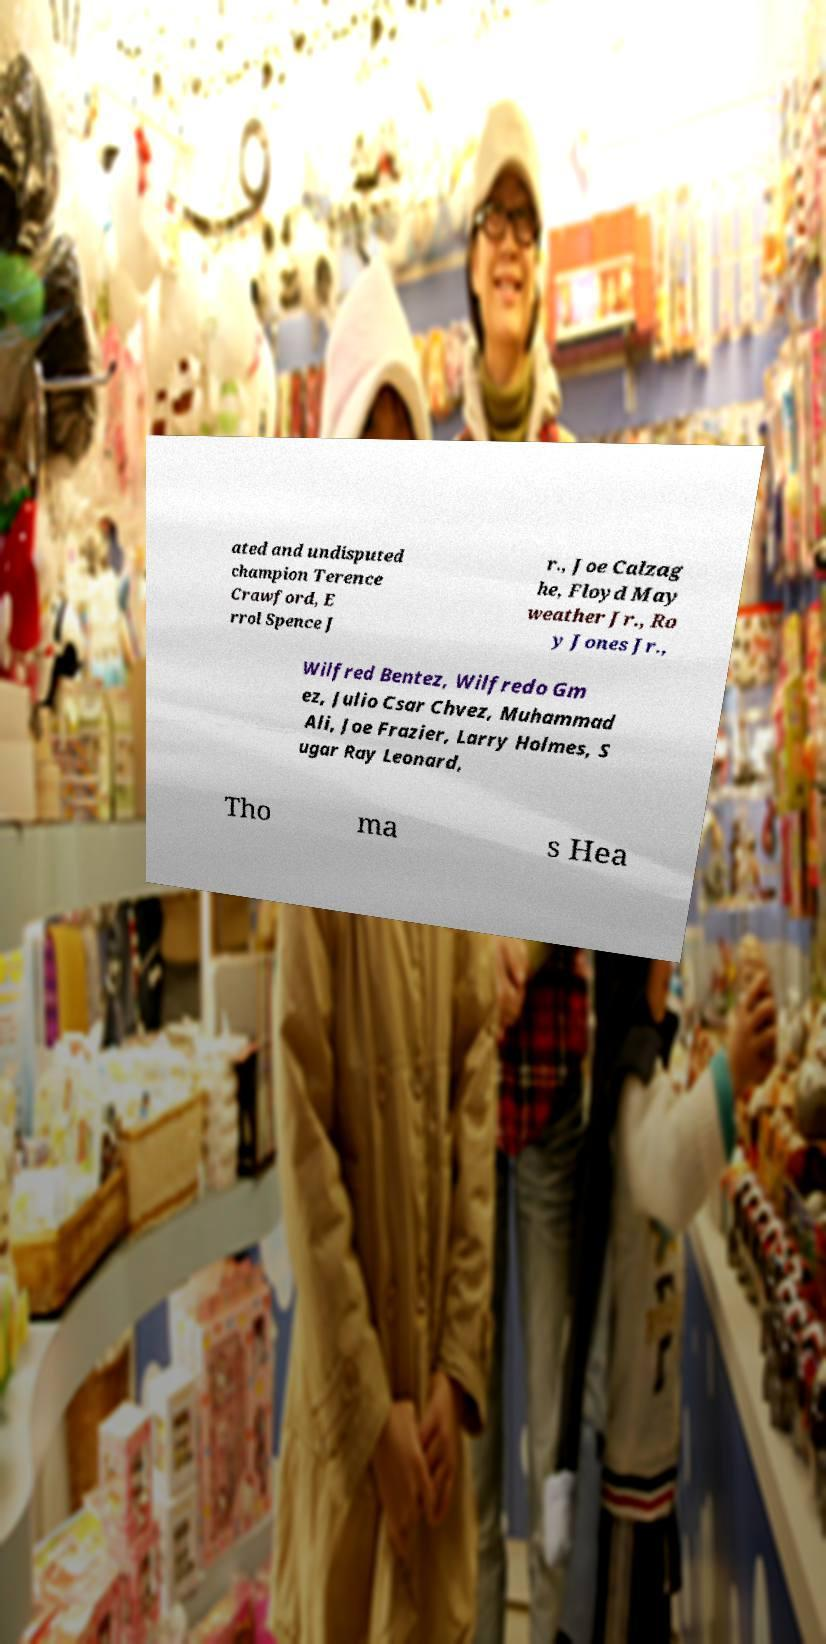I need the written content from this picture converted into text. Can you do that? ated and undisputed champion Terence Crawford, E rrol Spence J r., Joe Calzag he, Floyd May weather Jr., Ro y Jones Jr., Wilfred Bentez, Wilfredo Gm ez, Julio Csar Chvez, Muhammad Ali, Joe Frazier, Larry Holmes, S ugar Ray Leonard, Tho ma s Hea 